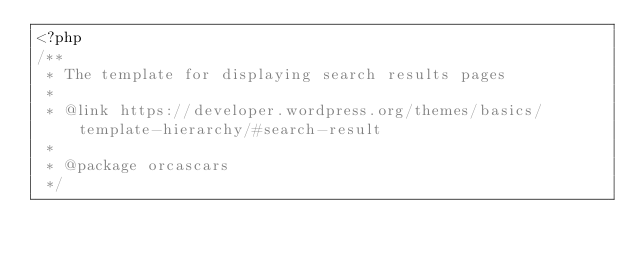<code> <loc_0><loc_0><loc_500><loc_500><_PHP_><?php
/**
 * The template for displaying search results pages
 *
 * @link https://developer.wordpress.org/themes/basics/template-hierarchy/#search-result
 *
 * @package orcascars
 */
</code> 